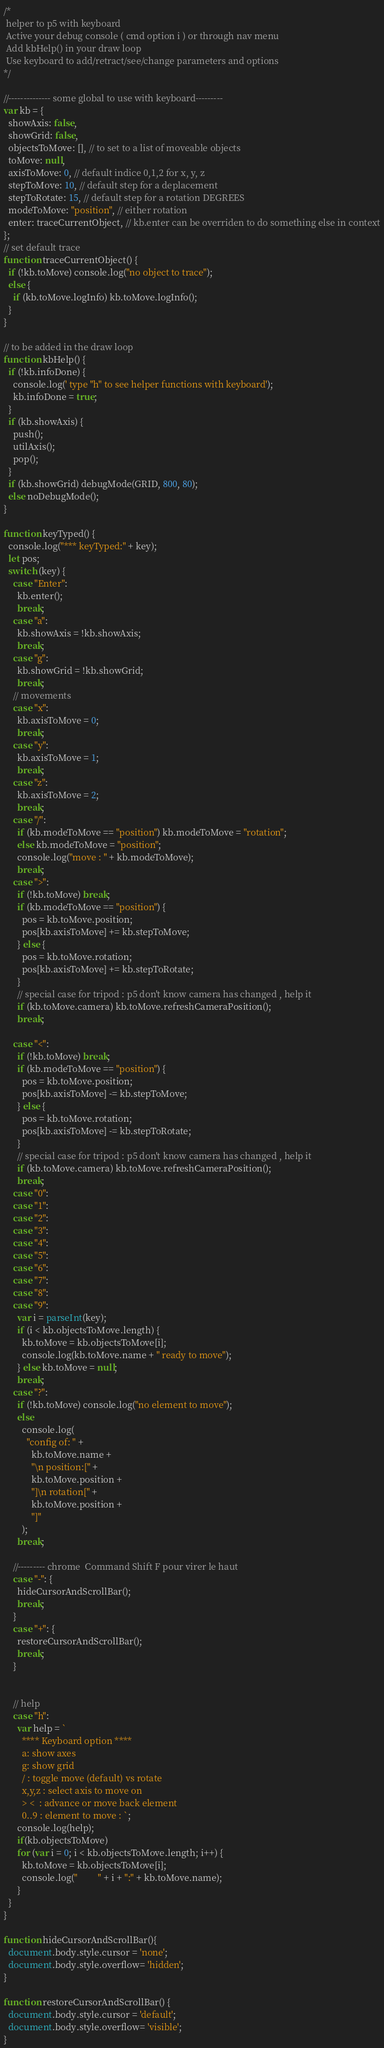<code> <loc_0><loc_0><loc_500><loc_500><_JavaScript_>/*
 helper to p5 with keyboard 
 Active your debug console ( cmd option i ) or through nav menu 
 Add kbHelp() in your draw loop 
 Use keyboard to add/retract/see/change parameters and options  
*/

//-------------- some global to use with keyboard---------
var kb = {
  showAxis: false,
  showGrid: false,
  objectsToMove: [], // to set to a list of moveable objects
  toMove: null,
  axisToMove: 0, // default indice 0,1,2 for x, y, z
  stepToMove: 10, // default step for a deplacement
  stepToRotate: 15, // default step for a rotation DEGREES
  modeToMove: "position", // either rotation
  enter: traceCurrentObject, // kb.enter can be overriden to do something else in context
};
// set default trace
function traceCurrentObject() {
  if (!kb.toMove) console.log("no object to trace");
  else {
    if (kb.toMove.logInfo) kb.toMove.logInfo();
  }
}

// to be added in the draw loop
function kbHelp() {
  if (!kb.infoDone) {
    console.log(' type "h" to see helper functions with keyboard');
    kb.infoDone = true;
  }
  if (kb.showAxis) {
    push();
    utilAxis();
    pop();
  }
  if (kb.showGrid) debugMode(GRID, 800, 80);
  else noDebugMode();
}

function keyTyped() {
  console.log("*** keyTyped:" + key);
  let pos;
  switch (key) {
    case "Enter":
      kb.enter();
      break;
    case "a":
      kb.showAxis = !kb.showAxis;
      break;
    case "g":
      kb.showGrid = !kb.showGrid;
      break;
    // movements
    case "x":
      kb.axisToMove = 0;
      break;
    case "y":
      kb.axisToMove = 1;
      break;
    case "z":
      kb.axisToMove = 2;
      break;
    case "/":
      if (kb.modeToMove == "position") kb.modeToMove = "rotation";
      else kb.modeToMove = "position";
      console.log("move : " + kb.modeToMove);
      break;
    case ">":
      if (!kb.toMove) break;
      if (kb.modeToMove == "position") {
        pos = kb.toMove.position;
        pos[kb.axisToMove] += kb.stepToMove;
      } else {
        pos = kb.toMove.rotation;
        pos[kb.axisToMove] += kb.stepToRotate;
      }
      // special case for tripod : p5 don't know camera has changed , help it
      if (kb.toMove.camera) kb.toMove.refreshCameraPosition();
      break;

    case "<":
      if (!kb.toMove) break;
      if (kb.modeToMove == "position") {
        pos = kb.toMove.position;
        pos[kb.axisToMove] -= kb.stepToMove;
      } else {
        pos = kb.toMove.rotation;
        pos[kb.axisToMove] -= kb.stepToRotate;
      }
      // special case for tripod : p5 don't know camera has changed , help it
      if (kb.toMove.camera) kb.toMove.refreshCameraPosition();
      break;
    case "0":
    case "1":
    case "2":
    case "3":
    case "4":
    case "5":
    case "6":
    case "7":
    case "8":
    case "9":
      var i = parseInt(key);
      if (i < kb.objectsToMove.length) {
        kb.toMove = kb.objectsToMove[i];
        console.log(kb.toMove.name + " ready to move");
      } else kb.toMove = null;
      break;
    case "?":
      if (!kb.toMove) console.log("no element to move");
      else
        console.log(
          "config of: " +
            kb.toMove.name +
            "\n position:[" +
            kb.toMove.position +
            "]\n rotation[" +
            kb.toMove.position +
            "]"
        );
      break;

    //--------- chrome  Command Shift F pour virer le haut
    case "-": {
      hideCursorAndScrollBar();
      break;
    }
    case "+": {
      restoreCursorAndScrollBar();
      break;
    }


    // help
    case "h":
      var help = `
        **** Keyboard option **** 
        a: show axes 
        g: show grid 
        / : toggle move (default) vs rotate  
        x,y,z : select axis to move on 
        > <  : advance or move back element
        0..9 : element to move : `;
      console.log(help);
      if(kb.objectsToMove)
      for (var i = 0; i < kb.objectsToMove.length; i++) {
        kb.toMove = kb.objectsToMove[i];
        console.log("         " + i + ":" + kb.toMove.name);
      }
  }
}

function hideCursorAndScrollBar(){
  document.body.style.cursor = 'none';
  document.body.style.overflow= 'hidden';
}

function restoreCursorAndScrollBar() {
  document.body.style.cursor = 'default';
  document.body.style.overflow= 'visible';
}</code> 